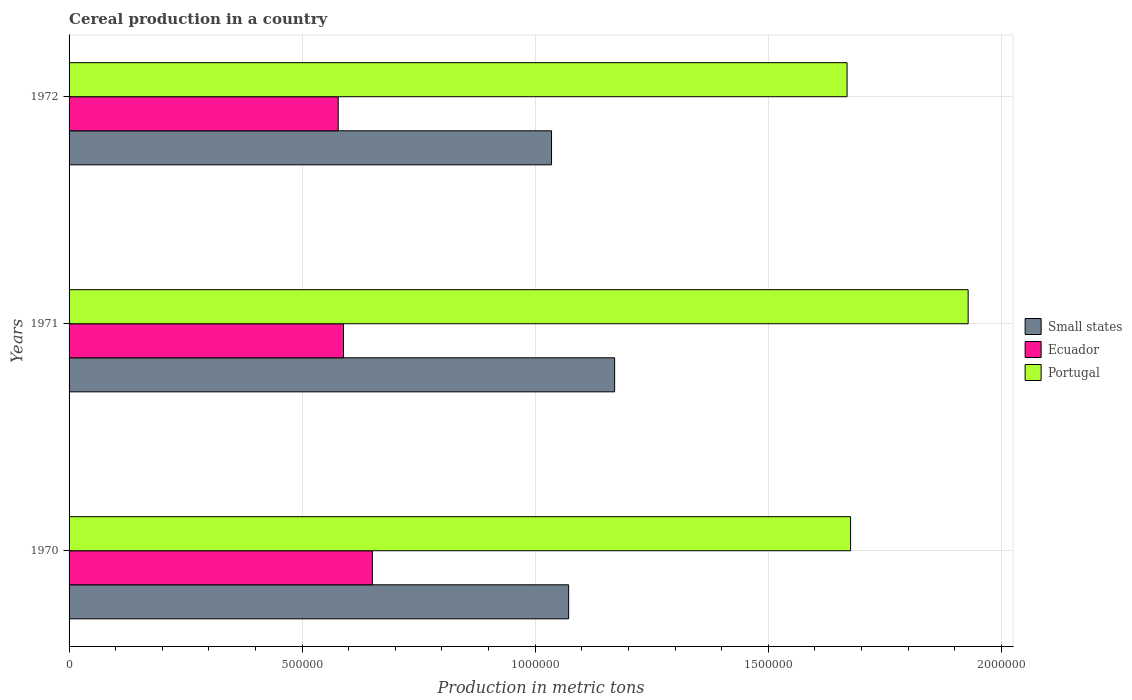How many different coloured bars are there?
Ensure brevity in your answer.  3. How many bars are there on the 2nd tick from the top?
Your response must be concise. 3. How many bars are there on the 1st tick from the bottom?
Provide a short and direct response. 3. What is the total cereal production in Portugal in 1971?
Your answer should be very brief. 1.93e+06. Across all years, what is the maximum total cereal production in Ecuador?
Your answer should be compact. 6.51e+05. Across all years, what is the minimum total cereal production in Ecuador?
Your answer should be compact. 5.77e+05. In which year was the total cereal production in Portugal maximum?
Provide a short and direct response. 1971. What is the total total cereal production in Small states in the graph?
Offer a terse response. 3.28e+06. What is the difference between the total cereal production in Small states in 1970 and that in 1972?
Your response must be concise. 3.67e+04. What is the difference between the total cereal production in Ecuador in 1970 and the total cereal production in Small states in 1972?
Keep it short and to the point. -3.84e+05. What is the average total cereal production in Small states per year?
Make the answer very short. 1.09e+06. In the year 1972, what is the difference between the total cereal production in Portugal and total cereal production in Ecuador?
Your answer should be compact. 1.09e+06. In how many years, is the total cereal production in Ecuador greater than 1600000 metric tons?
Provide a short and direct response. 0. What is the ratio of the total cereal production in Small states in 1970 to that in 1971?
Give a very brief answer. 0.92. Is the total cereal production in Small states in 1970 less than that in 1971?
Keep it short and to the point. Yes. What is the difference between the highest and the second highest total cereal production in Ecuador?
Offer a very short reply. 6.20e+04. What is the difference between the highest and the lowest total cereal production in Ecuador?
Make the answer very short. 7.34e+04. What does the 2nd bar from the top in 1971 represents?
Offer a very short reply. Ecuador. Is it the case that in every year, the sum of the total cereal production in Ecuador and total cereal production in Small states is greater than the total cereal production in Portugal?
Your answer should be compact. No. How many bars are there?
Make the answer very short. 9. Are the values on the major ticks of X-axis written in scientific E-notation?
Ensure brevity in your answer.  No. What is the title of the graph?
Offer a terse response. Cereal production in a country. What is the label or title of the X-axis?
Give a very brief answer. Production in metric tons. What is the label or title of the Y-axis?
Your answer should be very brief. Years. What is the Production in metric tons of Small states in 1970?
Provide a short and direct response. 1.07e+06. What is the Production in metric tons in Ecuador in 1970?
Keep it short and to the point. 6.51e+05. What is the Production in metric tons of Portugal in 1970?
Offer a terse response. 1.68e+06. What is the Production in metric tons of Small states in 1971?
Make the answer very short. 1.17e+06. What is the Production in metric tons in Ecuador in 1971?
Make the answer very short. 5.89e+05. What is the Production in metric tons of Portugal in 1971?
Ensure brevity in your answer.  1.93e+06. What is the Production in metric tons of Small states in 1972?
Keep it short and to the point. 1.04e+06. What is the Production in metric tons of Ecuador in 1972?
Make the answer very short. 5.77e+05. What is the Production in metric tons in Portugal in 1972?
Your answer should be compact. 1.67e+06. Across all years, what is the maximum Production in metric tons in Small states?
Offer a terse response. 1.17e+06. Across all years, what is the maximum Production in metric tons of Ecuador?
Make the answer very short. 6.51e+05. Across all years, what is the maximum Production in metric tons of Portugal?
Provide a short and direct response. 1.93e+06. Across all years, what is the minimum Production in metric tons in Small states?
Provide a short and direct response. 1.04e+06. Across all years, what is the minimum Production in metric tons in Ecuador?
Ensure brevity in your answer.  5.77e+05. Across all years, what is the minimum Production in metric tons in Portugal?
Provide a succinct answer. 1.67e+06. What is the total Production in metric tons in Small states in the graph?
Your answer should be compact. 3.28e+06. What is the total Production in metric tons in Ecuador in the graph?
Your response must be concise. 1.82e+06. What is the total Production in metric tons of Portugal in the graph?
Offer a very short reply. 5.27e+06. What is the difference between the Production in metric tons of Small states in 1970 and that in 1971?
Make the answer very short. -9.87e+04. What is the difference between the Production in metric tons in Ecuador in 1970 and that in 1971?
Your answer should be compact. 6.20e+04. What is the difference between the Production in metric tons in Portugal in 1970 and that in 1971?
Offer a very short reply. -2.52e+05. What is the difference between the Production in metric tons in Small states in 1970 and that in 1972?
Offer a very short reply. 3.67e+04. What is the difference between the Production in metric tons of Ecuador in 1970 and that in 1972?
Make the answer very short. 7.34e+04. What is the difference between the Production in metric tons of Portugal in 1970 and that in 1972?
Keep it short and to the point. 7538. What is the difference between the Production in metric tons of Small states in 1971 and that in 1972?
Make the answer very short. 1.35e+05. What is the difference between the Production in metric tons in Ecuador in 1971 and that in 1972?
Give a very brief answer. 1.13e+04. What is the difference between the Production in metric tons in Portugal in 1971 and that in 1972?
Your response must be concise. 2.60e+05. What is the difference between the Production in metric tons of Small states in 1970 and the Production in metric tons of Ecuador in 1971?
Your answer should be compact. 4.83e+05. What is the difference between the Production in metric tons of Small states in 1970 and the Production in metric tons of Portugal in 1971?
Make the answer very short. -8.57e+05. What is the difference between the Production in metric tons of Ecuador in 1970 and the Production in metric tons of Portugal in 1971?
Offer a terse response. -1.28e+06. What is the difference between the Production in metric tons of Small states in 1970 and the Production in metric tons of Ecuador in 1972?
Ensure brevity in your answer.  4.94e+05. What is the difference between the Production in metric tons in Small states in 1970 and the Production in metric tons in Portugal in 1972?
Your answer should be very brief. -5.97e+05. What is the difference between the Production in metric tons of Ecuador in 1970 and the Production in metric tons of Portugal in 1972?
Provide a succinct answer. -1.02e+06. What is the difference between the Production in metric tons in Small states in 1971 and the Production in metric tons in Ecuador in 1972?
Your answer should be compact. 5.93e+05. What is the difference between the Production in metric tons of Small states in 1971 and the Production in metric tons of Portugal in 1972?
Give a very brief answer. -4.99e+05. What is the difference between the Production in metric tons in Ecuador in 1971 and the Production in metric tons in Portugal in 1972?
Offer a very short reply. -1.08e+06. What is the average Production in metric tons in Small states per year?
Make the answer very short. 1.09e+06. What is the average Production in metric tons of Ecuador per year?
Offer a very short reply. 6.06e+05. What is the average Production in metric tons of Portugal per year?
Your answer should be very brief. 1.76e+06. In the year 1970, what is the difference between the Production in metric tons in Small states and Production in metric tons in Ecuador?
Your answer should be compact. 4.21e+05. In the year 1970, what is the difference between the Production in metric tons in Small states and Production in metric tons in Portugal?
Ensure brevity in your answer.  -6.05e+05. In the year 1970, what is the difference between the Production in metric tons in Ecuador and Production in metric tons in Portugal?
Provide a short and direct response. -1.03e+06. In the year 1971, what is the difference between the Production in metric tons in Small states and Production in metric tons in Ecuador?
Keep it short and to the point. 5.82e+05. In the year 1971, what is the difference between the Production in metric tons in Small states and Production in metric tons in Portugal?
Your answer should be compact. -7.58e+05. In the year 1971, what is the difference between the Production in metric tons of Ecuador and Production in metric tons of Portugal?
Provide a succinct answer. -1.34e+06. In the year 1972, what is the difference between the Production in metric tons in Small states and Production in metric tons in Ecuador?
Your answer should be compact. 4.58e+05. In the year 1972, what is the difference between the Production in metric tons in Small states and Production in metric tons in Portugal?
Make the answer very short. -6.34e+05. In the year 1972, what is the difference between the Production in metric tons in Ecuador and Production in metric tons in Portugal?
Your answer should be compact. -1.09e+06. What is the ratio of the Production in metric tons of Small states in 1970 to that in 1971?
Provide a succinct answer. 0.92. What is the ratio of the Production in metric tons of Ecuador in 1970 to that in 1971?
Give a very brief answer. 1.11. What is the ratio of the Production in metric tons in Portugal in 1970 to that in 1971?
Offer a terse response. 0.87. What is the ratio of the Production in metric tons of Small states in 1970 to that in 1972?
Give a very brief answer. 1.04. What is the ratio of the Production in metric tons in Ecuador in 1970 to that in 1972?
Ensure brevity in your answer.  1.13. What is the ratio of the Production in metric tons of Small states in 1971 to that in 1972?
Ensure brevity in your answer.  1.13. What is the ratio of the Production in metric tons in Ecuador in 1971 to that in 1972?
Provide a short and direct response. 1.02. What is the ratio of the Production in metric tons of Portugal in 1971 to that in 1972?
Your response must be concise. 1.16. What is the difference between the highest and the second highest Production in metric tons in Small states?
Your answer should be very brief. 9.87e+04. What is the difference between the highest and the second highest Production in metric tons of Ecuador?
Ensure brevity in your answer.  6.20e+04. What is the difference between the highest and the second highest Production in metric tons of Portugal?
Offer a terse response. 2.52e+05. What is the difference between the highest and the lowest Production in metric tons of Small states?
Your answer should be very brief. 1.35e+05. What is the difference between the highest and the lowest Production in metric tons of Ecuador?
Provide a succinct answer. 7.34e+04. What is the difference between the highest and the lowest Production in metric tons in Portugal?
Your response must be concise. 2.60e+05. 